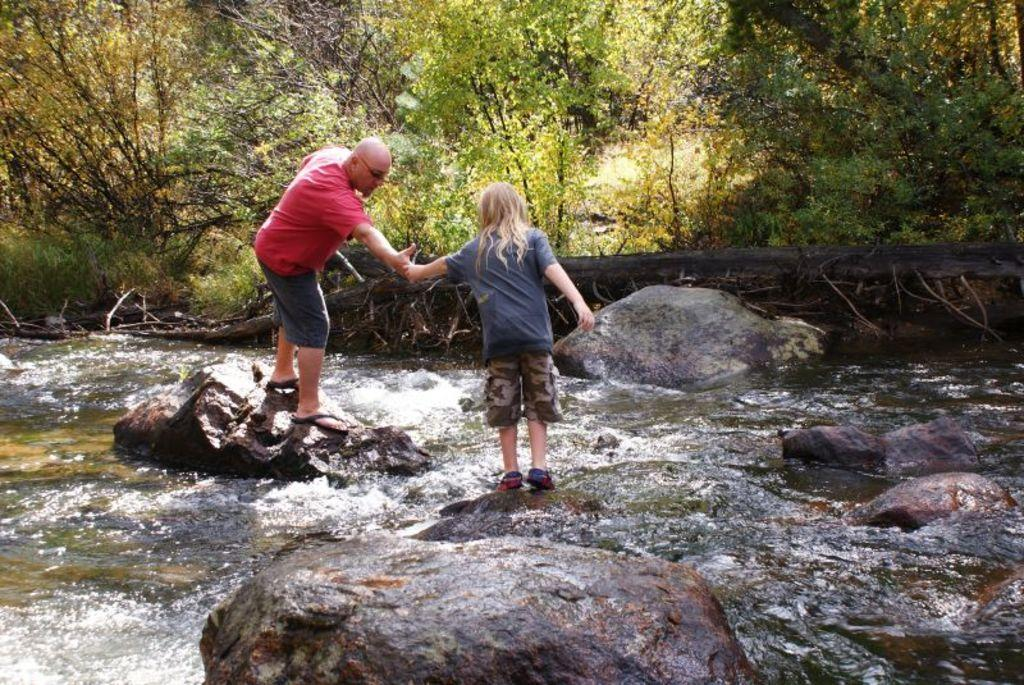What are the persons in the image doing on the rocks? The persons in the image are standing on the rocks and holding hands. What can be seen in the water in the image? The facts do not specify what can be seen in the water. What type of natural features are present in the image? There are rocks and trees in the image. Can you tell me how many times the persons in the image have flown to the moon? There is no indication in the image that the persons have flown to the moon, so it cannot be determined from the picture. 